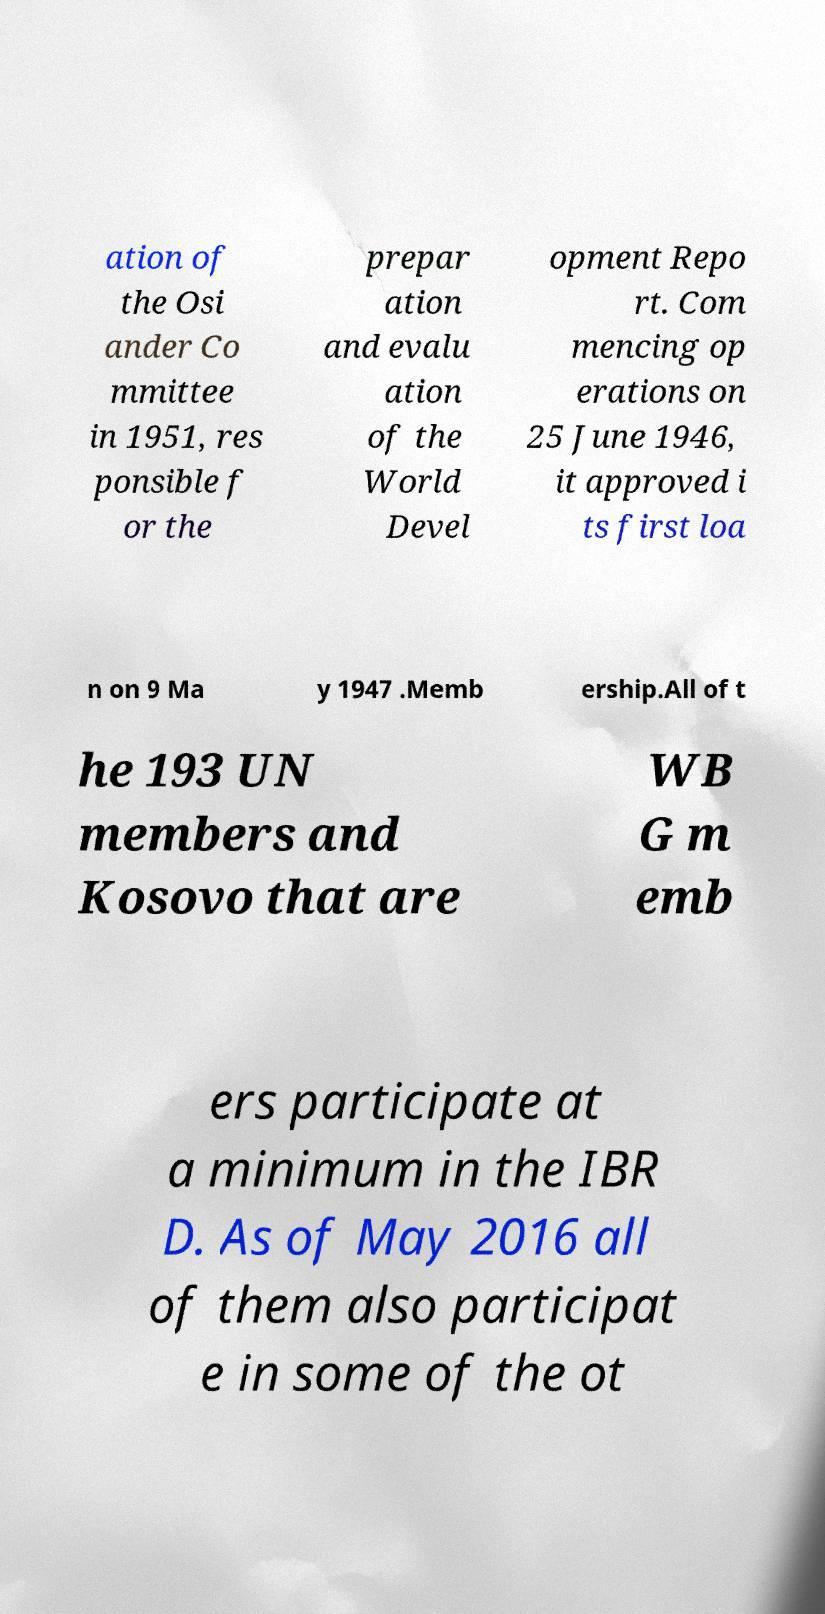Can you read and provide the text displayed in the image?This photo seems to have some interesting text. Can you extract and type it out for me? ation of the Osi ander Co mmittee in 1951, res ponsible f or the prepar ation and evalu ation of the World Devel opment Repo rt. Com mencing op erations on 25 June 1946, it approved i ts first loa n on 9 Ma y 1947 .Memb ership.All of t he 193 UN members and Kosovo that are WB G m emb ers participate at a minimum in the IBR D. As of May 2016 all of them also participat e in some of the ot 